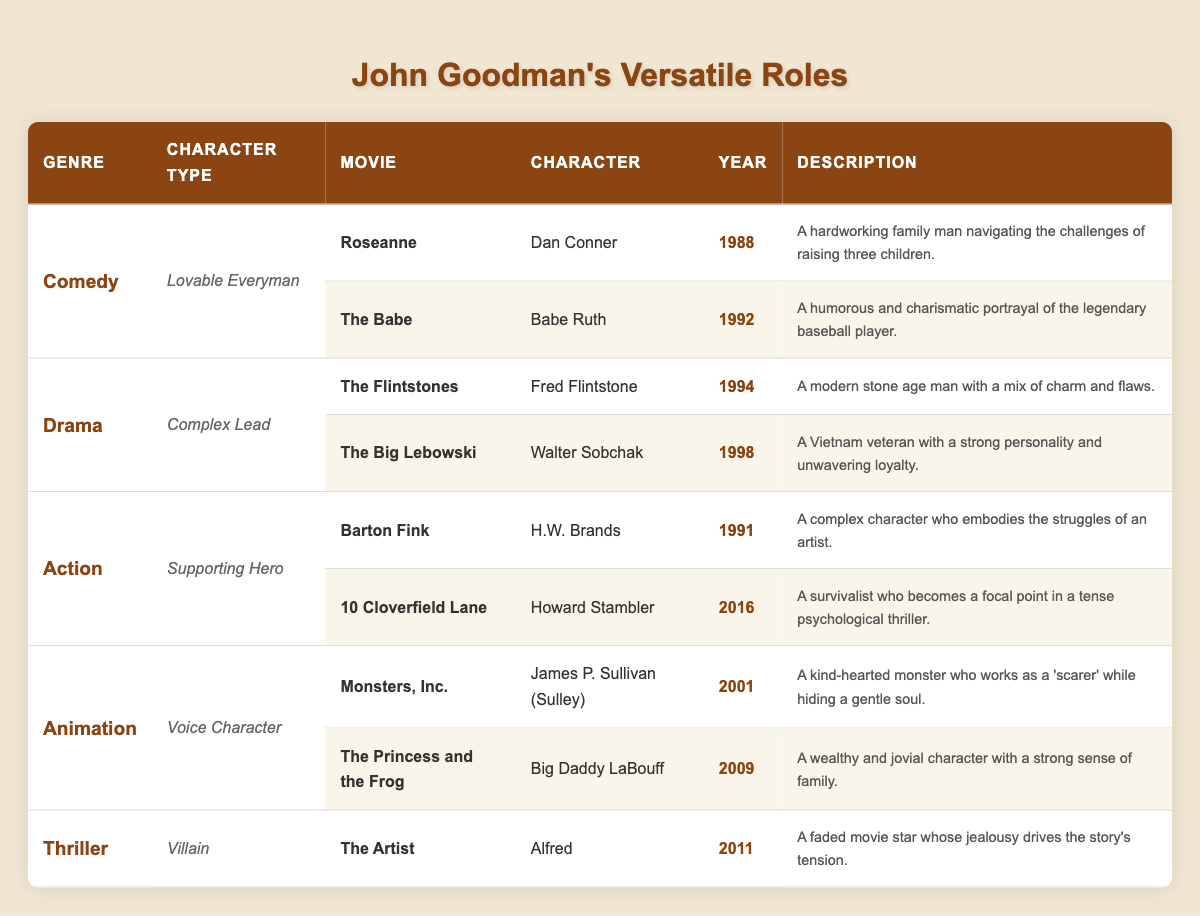What are the genres represented in the table? The table lists several genres: Comedy, Drama, Action, Animation, and Thriller. Each genre is specified in its respective row.
Answer: Comedy, Drama, Action, Animation, Thriller How many roles did John Goodman play in the Comedy genre? In the table, there are two roles listed under the Comedy genre: "Dan Conner" from "Roseanne" and "Babe Ruth" from "The Babe." Therefore, the total is 2 roles.
Answer: 2 Which character did John Goodman portray in the movie "The Big Lebowski"? In the table, it states that John Goodman played the character "Walter Sobchak" in "The Big Lebowski."
Answer: Walter Sobchak What year was "Monsters, Inc." released? The table indicates that "Monsters, Inc." was released in 2001, which is stated alongside the role details.
Answer: 2001 Is "The Artist" classified under the Action genre? The table categorizes "The Artist" under the Thriller genre, not Action, which confirms this statement is false.
Answer: No What's the total number of roles listed in the Animation genre? There are two roles in the Animation genre as indicated by the rows dedicated to this genre: "James P. Sullivan (Sulley)" from "Monsters, Inc." and "Big Daddy LaBouff" from "The Princess and the Frog." Hence, the total is 2 roles.
Answer: 2 Which character type appears the most in the table? The table shows that the "Lovable Everyman" and "Complex Lead" both have 2 roles, while the others have 1. Thus, both “Lovable Everyman” and “Complex Lead” types appear the most frequently.
Answer: Lovable Everyman and Complex Lead What is the description of the character "Howard Stambler"? In the table, it specifies that Howard Stambler, from "10 Cloverfield Lane," is described as "A survivalist who becomes a focal point in a tense psychological thriller."
Answer: A survivalist in a tense psychological thriller How many character types are associated with the Drama genre? There is one character type listed under the Drama genre, which is "Complex Lead," associated with both roles in that genre.
Answer: 1 Which genre features a character type of "Villain"? According to the table, the Thriller genre features the character type of "Villain," with the role of "Alfred" from "The Artist."
Answer: Thriller 